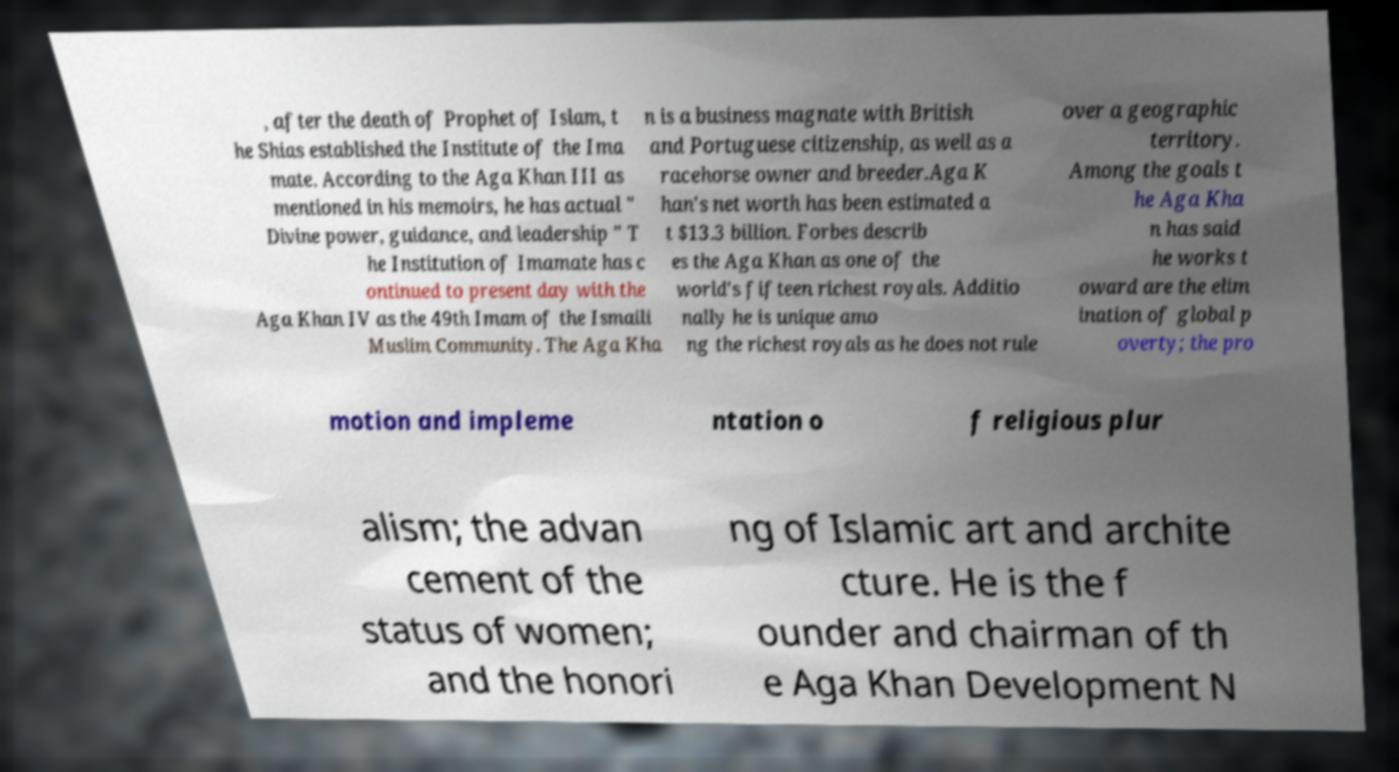Please identify and transcribe the text found in this image. , after the death of Prophet of Islam, t he Shias established the Institute of the Ima mate. According to the Aga Khan III as mentioned in his memoirs, he has actual " Divine power, guidance, and leadership " T he Institution of Imamate has c ontinued to present day with the Aga Khan IV as the 49th Imam of the Ismaili Muslim Community. The Aga Kha n is a business magnate with British and Portuguese citizenship, as well as a racehorse owner and breeder.Aga K han's net worth has been estimated a t $13.3 billion. Forbes describ es the Aga Khan as one of the world's fifteen richest royals. Additio nally he is unique amo ng the richest royals as he does not rule over a geographic territory. Among the goals t he Aga Kha n has said he works t oward are the elim ination of global p overty; the pro motion and impleme ntation o f religious plur alism; the advan cement of the status of women; and the honori ng of Islamic art and archite cture. He is the f ounder and chairman of th e Aga Khan Development N 